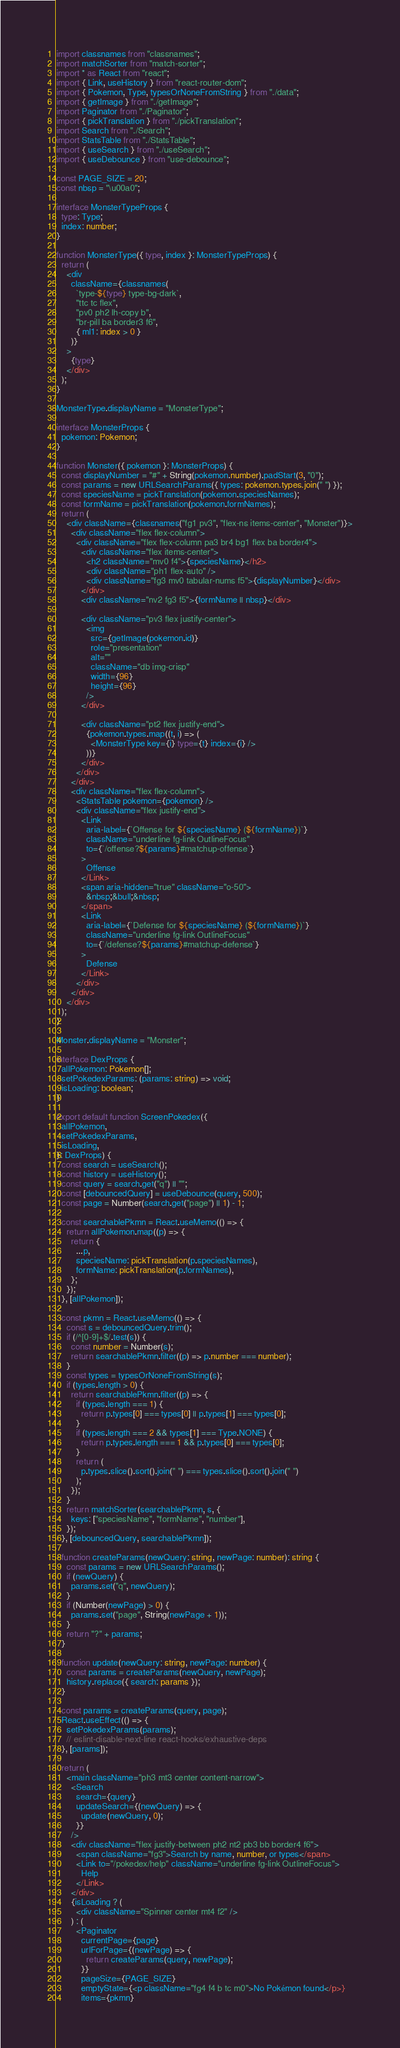Convert code to text. <code><loc_0><loc_0><loc_500><loc_500><_TypeScript_>import classnames from "classnames";
import matchSorter from "match-sorter";
import * as React from "react";
import { Link, useHistory } from "react-router-dom";
import { Pokemon, Type, typesOrNoneFromString } from "./data";
import { getImage } from "./getImage";
import Paginator from "./Paginator";
import { pickTranslation } from "./pickTranslation";
import Search from "./Search";
import StatsTable from "./StatsTable";
import { useSearch } from "./useSearch";
import { useDebounce } from "use-debounce";

const PAGE_SIZE = 20;
const nbsp = "\u00a0";

interface MonsterTypeProps {
  type: Type;
  index: number;
}

function MonsterType({ type, index }: MonsterTypeProps) {
  return (
    <div
      className={classnames(
        `type-${type} type-bg-dark`,
        "ttc tc flex",
        "pv0 ph2 lh-copy b",
        "br-pill ba border3 f6",
        { ml1: index > 0 }
      )}
    >
      {type}
    </div>
  );
}

MonsterType.displayName = "MonsterType";

interface MonsterProps {
  pokemon: Pokemon;
}

function Monster({ pokemon }: MonsterProps) {
  const displayNumber = "#" + String(pokemon.number).padStart(3, "0");
  const params = new URLSearchParams({ types: pokemon.types.join(" ") });
  const speciesName = pickTranslation(pokemon.speciesNames);
  const formName = pickTranslation(pokemon.formNames);
  return (
    <div className={classnames("fg1 pv3", "flex-ns items-center", "Monster")}>
      <div className="flex flex-column">
        <div className="flex flex-column pa3 br4 bg1 flex ba border4">
          <div className="flex items-center">
            <h2 className="mv0 f4">{speciesName}</h2>
            <div className="ph1 flex-auto" />
            <div className="fg3 mv0 tabular-nums f5">{displayNumber}</div>
          </div>
          <div className="nv2 fg3 f5">{formName || nbsp}</div>

          <div className="pv3 flex justify-center">
            <img
              src={getImage(pokemon.id)}
              role="presentation"
              alt=""
              className="db img-crisp"
              width={96}
              height={96}
            />
          </div>

          <div className="pt2 flex justify-end">
            {pokemon.types.map((t, i) => (
              <MonsterType key={i} type={t} index={i} />
            ))}
          </div>
        </div>
      </div>
      <div className="flex flex-column">
        <StatsTable pokemon={pokemon} />
        <div className="flex justify-end">
          <Link
            aria-label={`Offense for ${speciesName} (${formName})`}
            className="underline fg-link OutlineFocus"
            to={`/offense?${params}#matchup-offense`}
          >
            Offense
          </Link>
          <span aria-hidden="true" className="o-50">
            &nbsp;&bull;&nbsp;
          </span>
          <Link
            aria-label={`Defense for ${speciesName} (${formName})`}
            className="underline fg-link OutlineFocus"
            to={`/defense?${params}#matchup-defense`}
          >
            Defense
          </Link>
        </div>
      </div>
    </div>
  );
}

Monster.displayName = "Monster";

interface DexProps {
  allPokemon: Pokemon[];
  setPokedexParams: (params: string) => void;
  isLoading: boolean;
}

export default function ScreenPokedex({
  allPokemon,
  setPokedexParams,
  isLoading,
}: DexProps) {
  const search = useSearch();
  const history = useHistory();
  const query = search.get("q") || "";
  const [debouncedQuery] = useDebounce(query, 500);
  const page = Number(search.get("page") || 1) - 1;

  const searchablePkmn = React.useMemo(() => {
    return allPokemon.map((p) => {
      return {
        ...p,
        speciesName: pickTranslation(p.speciesNames),
        formName: pickTranslation(p.formNames),
      };
    });
  }, [allPokemon]);

  const pkmn = React.useMemo(() => {
    const s = debouncedQuery.trim();
    if (/^[0-9]+$/.test(s)) {
      const number = Number(s);
      return searchablePkmn.filter((p) => p.number === number);
    }
    const types = typesOrNoneFromString(s);
    if (types.length > 0) {
      return searchablePkmn.filter((p) => {
        if (types.length === 1) {
          return p.types[0] === types[0] || p.types[1] === types[0];
        }
        if (types.length === 2 && types[1] === Type.NONE) {
          return p.types.length === 1 && p.types[0] === types[0];
        }
        return (
          p.types.slice().sort().join(" ") === types.slice().sort().join(" ")
        );
      });
    }
    return matchSorter(searchablePkmn, s, {
      keys: ["speciesName", "formName", "number"],
    });
  }, [debouncedQuery, searchablePkmn]);

  function createParams(newQuery: string, newPage: number): string {
    const params = new URLSearchParams();
    if (newQuery) {
      params.set("q", newQuery);
    }
    if (Number(newPage) > 0) {
      params.set("page", String(newPage + 1));
    }
    return "?" + params;
  }

  function update(newQuery: string, newPage: number) {
    const params = createParams(newQuery, newPage);
    history.replace({ search: params });
  }

  const params = createParams(query, page);
  React.useEffect(() => {
    setPokedexParams(params);
    // eslint-disable-next-line react-hooks/exhaustive-deps
  }, [params]);

  return (
    <main className="ph3 mt3 center content-narrow">
      <Search
        search={query}
        updateSearch={(newQuery) => {
          update(newQuery, 0);
        }}
      />
      <div className="flex justify-between ph2 nt2 pb3 bb border4 f6">
        <span className="fg3">Search by name, number, or types</span>
        <Link to="/pokedex/help" className="underline fg-link OutlineFocus">
          Help
        </Link>
      </div>
      {isLoading ? (
        <div className="Spinner center mt4 f2" />
      ) : (
        <Paginator
          currentPage={page}
          urlForPage={(newPage) => {
            return createParams(query, newPage);
          }}
          pageSize={PAGE_SIZE}
          emptyState={<p className="fg4 f4 b tc m0">No Pokémon found</p>}
          items={pkmn}</code> 